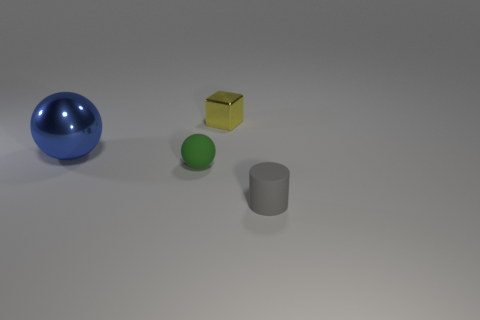What number of matte balls are the same size as the blue shiny thing?
Your response must be concise. 0. There is a small rubber object to the left of the small shiny thing; how many tiny things are on the right side of it?
Offer a terse response. 2. There is a thing that is both behind the rubber sphere and to the left of the tiny yellow metal cube; how big is it?
Offer a terse response. Large. Is the number of small matte things greater than the number of large cyan matte things?
Ensure brevity in your answer.  Yes. Are there any other large objects that have the same color as the large object?
Offer a terse response. No. There is a matte object that is on the left side of the gray cylinder; is its size the same as the yellow object?
Keep it short and to the point. Yes. Is the number of yellow metallic things less than the number of big gray rubber balls?
Provide a short and direct response. No. Are there any big cyan cubes made of the same material as the gray cylinder?
Your response must be concise. No. There is a tiny object right of the yellow cube; what shape is it?
Your response must be concise. Cylinder. Is the color of the shiny object on the left side of the small matte sphere the same as the rubber ball?
Offer a terse response. No. 